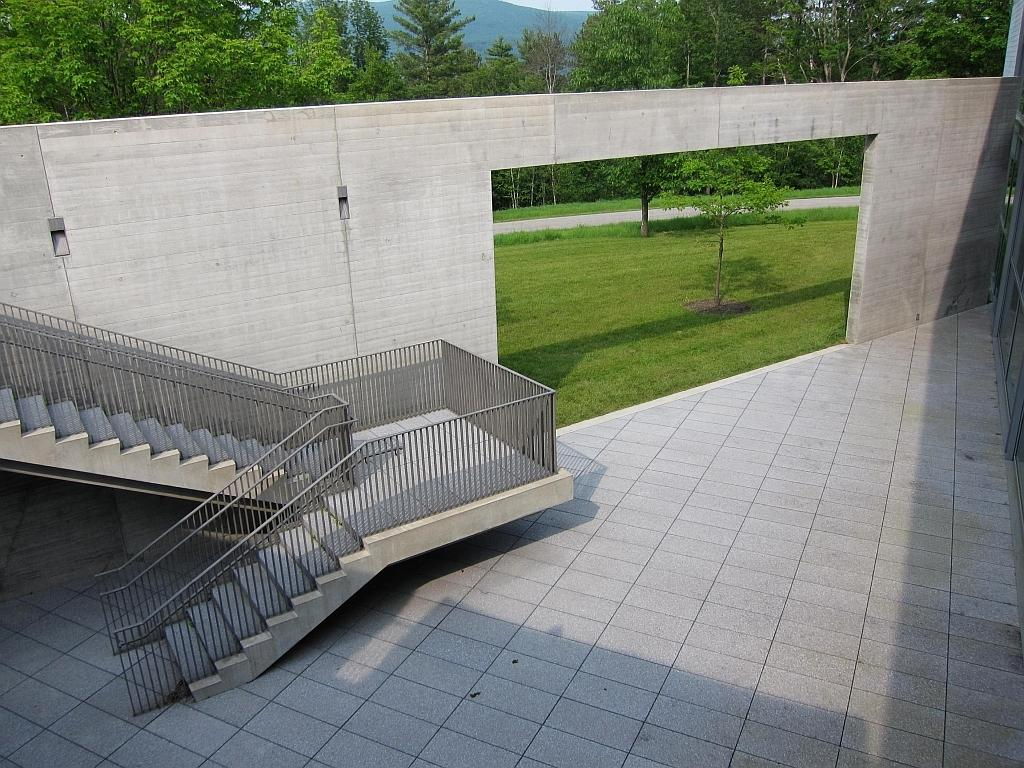What type of structure can be seen in the image? There are staircases in the image. What is the background of the image made of? There is a wall in the image. What type of vegetation is present in the image? Grass is present in the image. What other natural elements can be seen in the image? There are trees in the image. What country is mentioned in the verse that is visible in the image? There is no verse present in the image, so it is not possible to determine which country might be mentioned. 